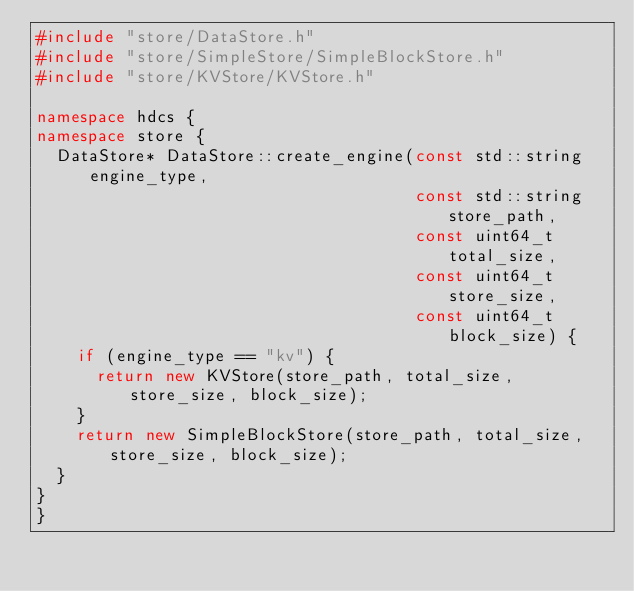<code> <loc_0><loc_0><loc_500><loc_500><_C++_>#include "store/DataStore.h"
#include "store/SimpleStore/SimpleBlockStore.h"
#include "store/KVStore/KVStore.h"

namespace hdcs {
namespace store {
  DataStore* DataStore::create_engine(const std::string engine_type,
                                      const std::string store_path,
                                      const uint64_t total_size,
                                      const uint64_t store_size,
                                      const uint64_t block_size) {
    if (engine_type == "kv") {
      return new KVStore(store_path, total_size, store_size, block_size);
    }
    return new SimpleBlockStore(store_path, total_size, store_size, block_size);
  }
}
}
</code> 